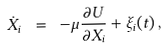Convert formula to latex. <formula><loc_0><loc_0><loc_500><loc_500>\dot { X _ { i } } \ = \ - \mu \frac { \partial U } { \partial X _ { i } } + \xi _ { i } ( t ) \, ,</formula> 